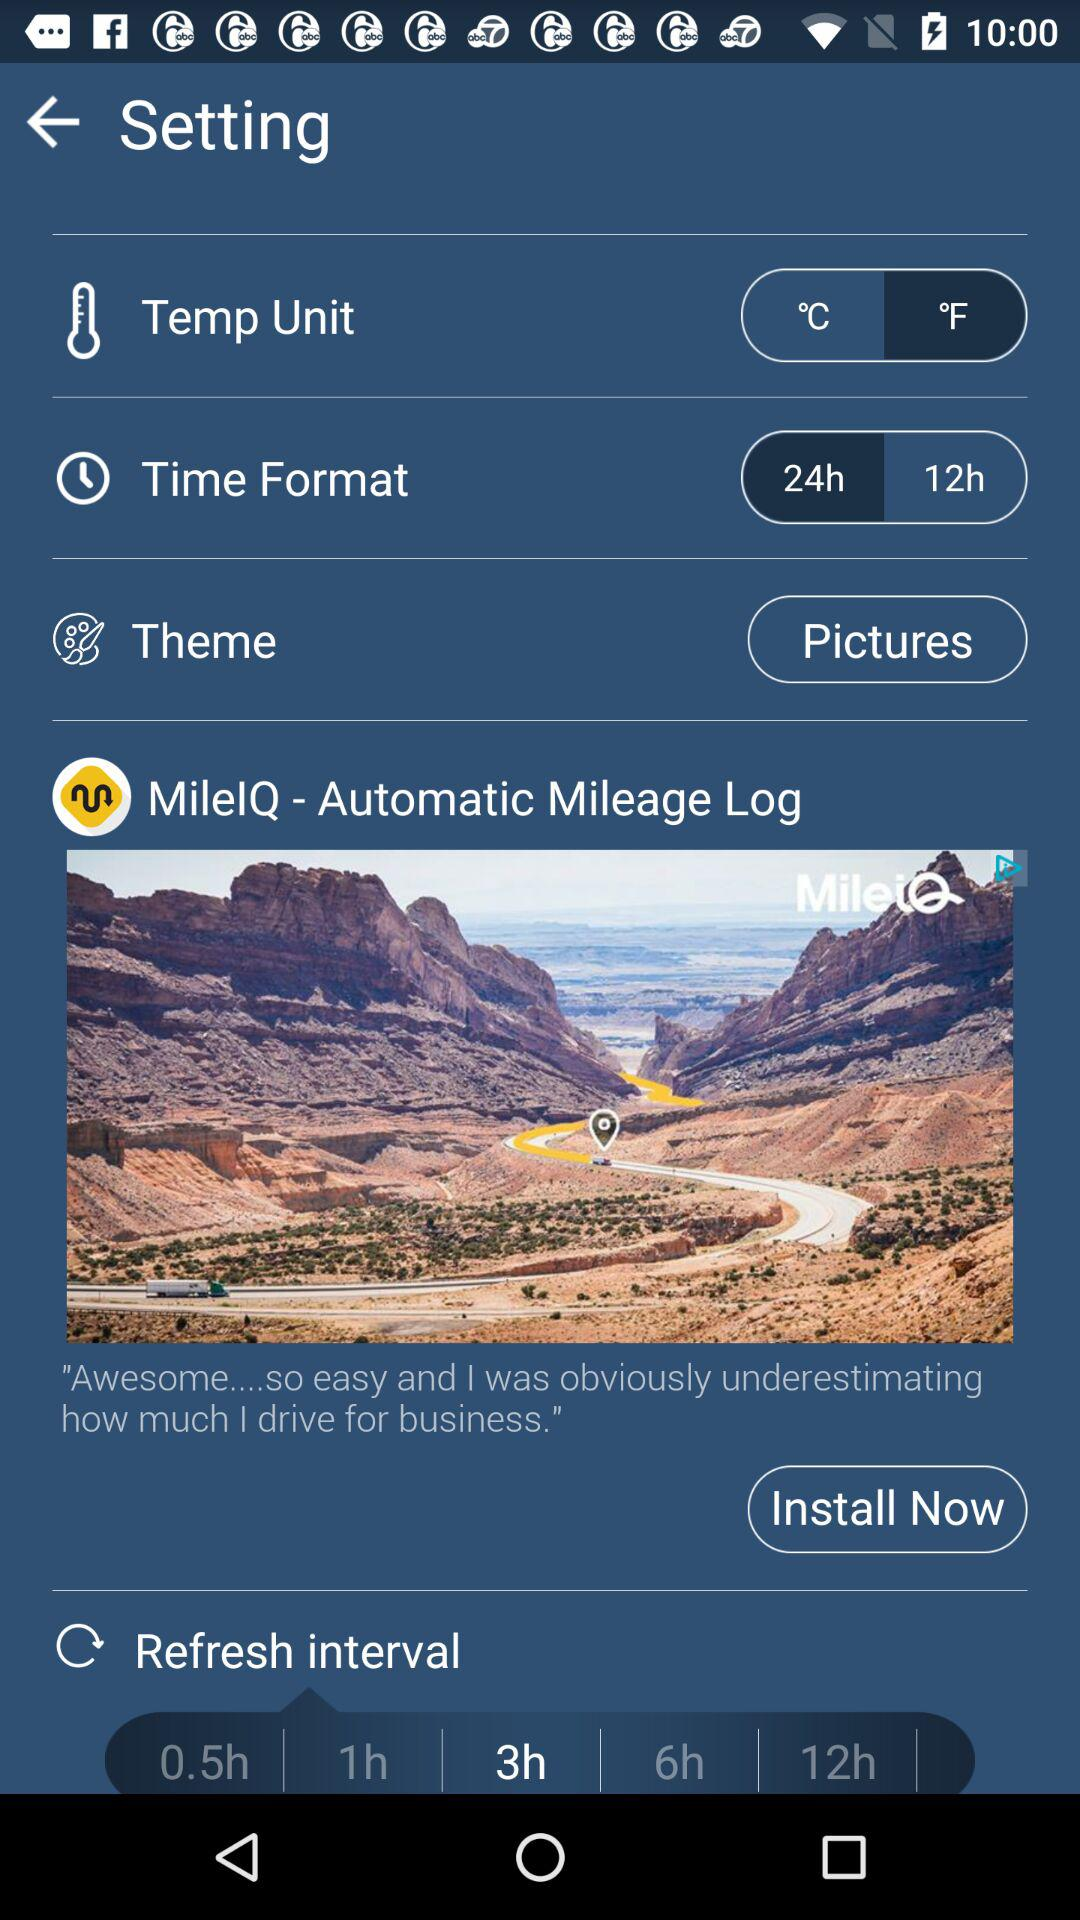What is the given theme? The given theme is "Pictures". 